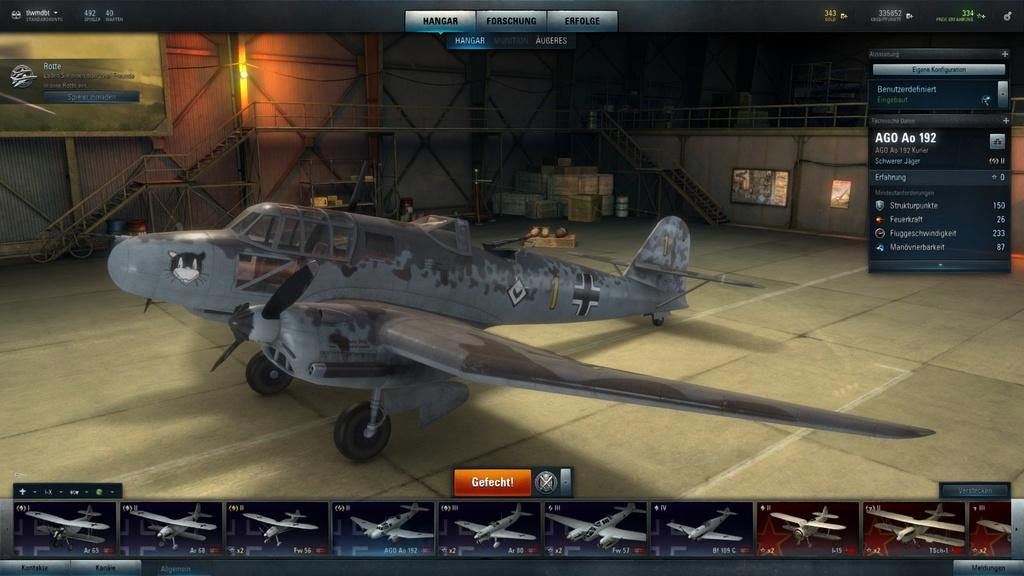Provide a one-sentence caption for the provided image. a game about planes with a orange button with Gefecht on it. 